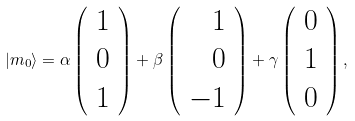<formula> <loc_0><loc_0><loc_500><loc_500>| m _ { 0 } \rangle = \alpha \left ( \begin{array} { r } 1 \\ 0 \\ 1 \end{array} \right ) + \beta \left ( \begin{array} { r } 1 \\ 0 \\ - 1 \end{array} \right ) + \gamma \left ( \begin{array} { r } 0 \\ 1 \\ 0 \end{array} \right ) ,</formula> 